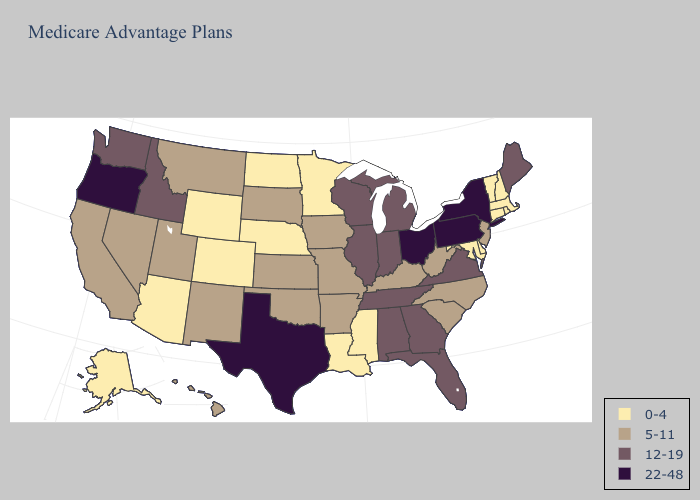Which states hav the highest value in the West?
Keep it brief. Oregon. Among the states that border Wisconsin , does Minnesota have the lowest value?
Short answer required. Yes. Name the states that have a value in the range 0-4?
Write a very short answer. Alaska, Arizona, Colorado, Connecticut, Delaware, Louisiana, Massachusetts, Maryland, Minnesota, Mississippi, North Dakota, Nebraska, New Hampshire, Rhode Island, Vermont, Wyoming. Name the states that have a value in the range 12-19?
Quick response, please. Alabama, Florida, Georgia, Idaho, Illinois, Indiana, Maine, Michigan, Tennessee, Virginia, Washington, Wisconsin. Among the states that border Georgia , does Tennessee have the lowest value?
Answer briefly. No. Among the states that border New York , does Pennsylvania have the lowest value?
Quick response, please. No. Does Georgia have a lower value than Texas?
Be succinct. Yes. Among the states that border Ohio , which have the lowest value?
Short answer required. Kentucky, West Virginia. Name the states that have a value in the range 12-19?
Concise answer only. Alabama, Florida, Georgia, Idaho, Illinois, Indiana, Maine, Michigan, Tennessee, Virginia, Washington, Wisconsin. Does Oklahoma have a lower value than Alabama?
Answer briefly. Yes. What is the value of Michigan?
Give a very brief answer. 12-19. Does Vermont have the same value as Mississippi?
Short answer required. Yes. What is the lowest value in the USA?
Give a very brief answer. 0-4. Does the map have missing data?
Keep it brief. No. 